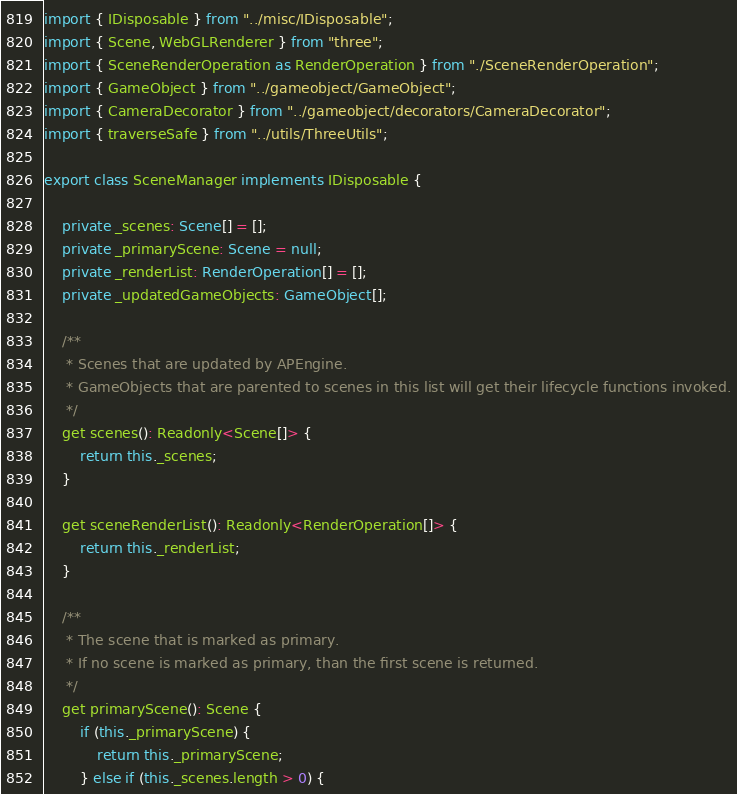<code> <loc_0><loc_0><loc_500><loc_500><_TypeScript_>import { IDisposable } from "../misc/IDisposable";
import { Scene, WebGLRenderer } from "three";
import { SceneRenderOperation as RenderOperation } from "./SceneRenderOperation";
import { GameObject } from "../gameobject/GameObject";
import { CameraDecorator } from "../gameobject/decorators/CameraDecorator";
import { traverseSafe } from "../utils/ThreeUtils";

export class SceneManager implements IDisposable {

    private _scenes: Scene[] = [];
    private _primaryScene: Scene = null;
    private _renderList: RenderOperation[] = [];
    private _updatedGameObjects: GameObject[];
    
    /**
     * Scenes that are updated by APEngine. 
     * GameObjects that are parented to scenes in this list will get their lifecycle functions invoked.
     */
    get scenes(): Readonly<Scene[]> {
        return this._scenes;
    }

    get sceneRenderList(): Readonly<RenderOperation[]> {
        return this._renderList;
    }

    /**
     * The scene that is marked as primary.
     * If no scene is marked as primary, than the first scene is returned.
     */
    get primaryScene(): Scene {
        if (this._primaryScene) {
            return this._primaryScene;
        } else if (this._scenes.length > 0) {</code> 